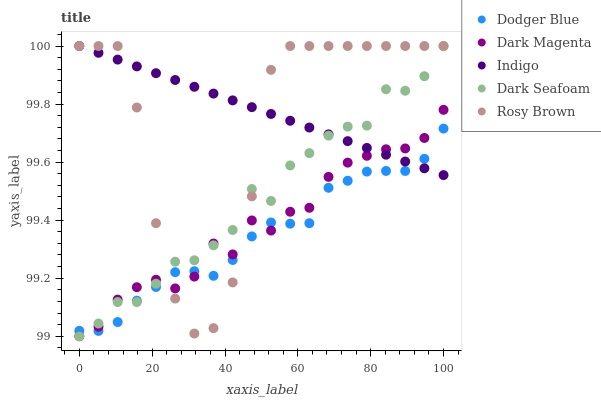Does Dodger Blue have the minimum area under the curve?
Answer yes or no. Yes. Does Indigo have the maximum area under the curve?
Answer yes or no. Yes. Does Dark Seafoam have the minimum area under the curve?
Answer yes or no. No. Does Dark Seafoam have the maximum area under the curve?
Answer yes or no. No. Is Indigo the smoothest?
Answer yes or no. Yes. Is Rosy Brown the roughest?
Answer yes or no. Yes. Is Dark Seafoam the smoothest?
Answer yes or no. No. Is Dark Seafoam the roughest?
Answer yes or no. No. Does Dark Seafoam have the lowest value?
Answer yes or no. Yes. Does Rosy Brown have the lowest value?
Answer yes or no. No. Does Rosy Brown have the highest value?
Answer yes or no. Yes. Does Dodger Blue have the highest value?
Answer yes or no. No. Does Rosy Brown intersect Dark Seafoam?
Answer yes or no. Yes. Is Rosy Brown less than Dark Seafoam?
Answer yes or no. No. Is Rosy Brown greater than Dark Seafoam?
Answer yes or no. No. 